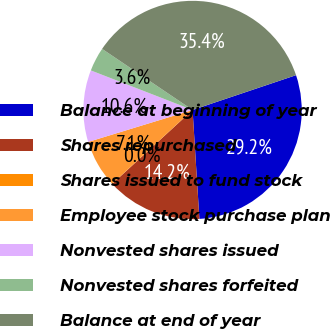Convert chart to OTSL. <chart><loc_0><loc_0><loc_500><loc_500><pie_chart><fcel>Balance at beginning of year<fcel>Shares repurchased<fcel>Shares issued to fund stock<fcel>Employee stock purchase plan<fcel>Nonvested shares issued<fcel>Nonvested shares forfeited<fcel>Balance at end of year<nl><fcel>29.17%<fcel>14.16%<fcel>0.02%<fcel>7.09%<fcel>10.63%<fcel>3.55%<fcel>35.38%<nl></chart> 